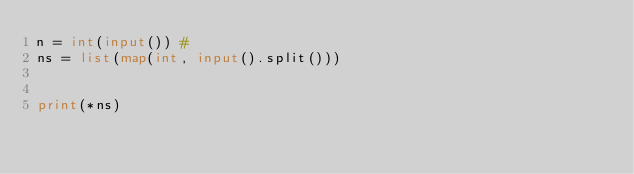Convert code to text. <code><loc_0><loc_0><loc_500><loc_500><_Python_>n = int(input()) #
ns = list(map(int, input().split()))


print(*ns)
</code> 